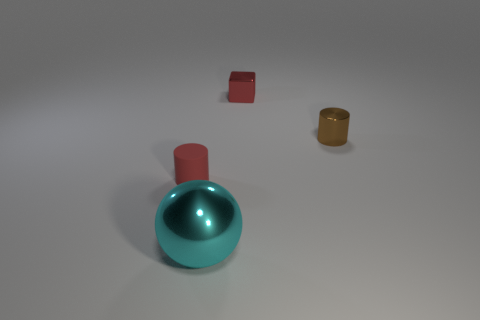Is there any other thing that is the same size as the cyan metallic thing?
Provide a succinct answer. No. Are there any red blocks left of the big cyan sphere?
Give a very brief answer. No. Is the cylinder that is on the left side of the small brown cylinder made of the same material as the cyan object?
Your response must be concise. No. Are there any other blocks of the same color as the block?
Make the answer very short. No. There is a small brown metallic thing; what shape is it?
Ensure brevity in your answer.  Cylinder. What is the color of the tiny metallic thing in front of the red object on the right side of the big cyan thing?
Make the answer very short. Brown. What is the size of the red thing behind the small rubber cylinder?
Provide a succinct answer. Small. Are there any small brown cylinders that have the same material as the red block?
Give a very brief answer. Yes. What number of tiny brown things have the same shape as the red metallic thing?
Your answer should be very brief. 0. What is the shape of the red object that is on the left side of the thing in front of the cylinder that is left of the metallic ball?
Your answer should be compact. Cylinder. 